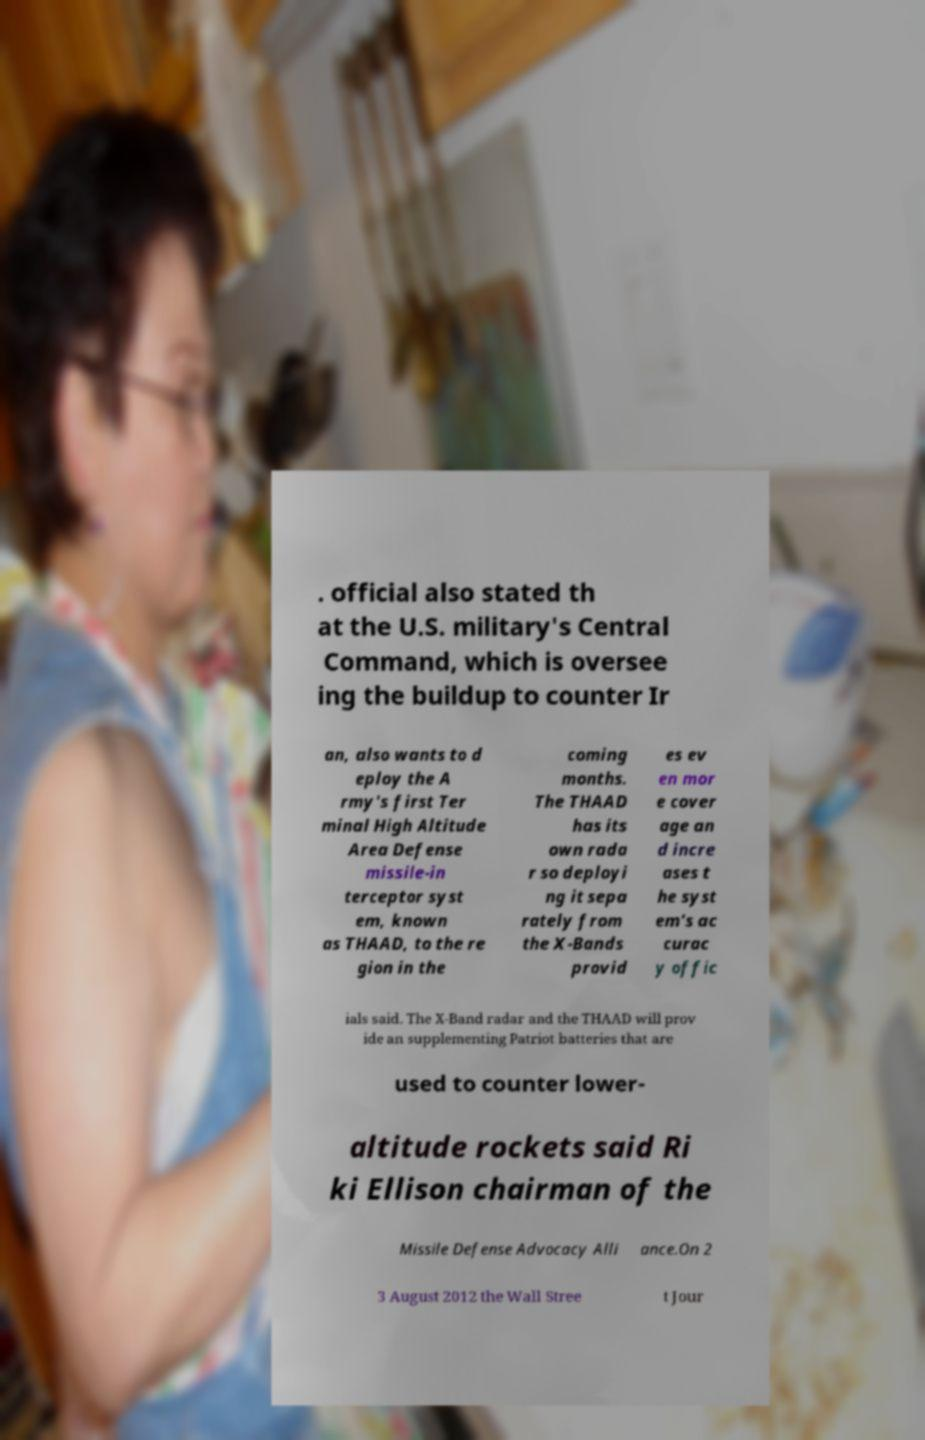What messages or text are displayed in this image? I need them in a readable, typed format. . official also stated th at the U.S. military's Central Command, which is oversee ing the buildup to counter Ir an, also wants to d eploy the A rmy's first Ter minal High Altitude Area Defense missile-in terceptor syst em, known as THAAD, to the re gion in the coming months. The THAAD has its own rada r so deployi ng it sepa rately from the X-Bands provid es ev en mor e cover age an d incre ases t he syst em's ac curac y offic ials said. The X-Band radar and the THAAD will prov ide an supplementing Patriot batteries that are used to counter lower- altitude rockets said Ri ki Ellison chairman of the Missile Defense Advocacy Alli ance.On 2 3 August 2012 the Wall Stree t Jour 